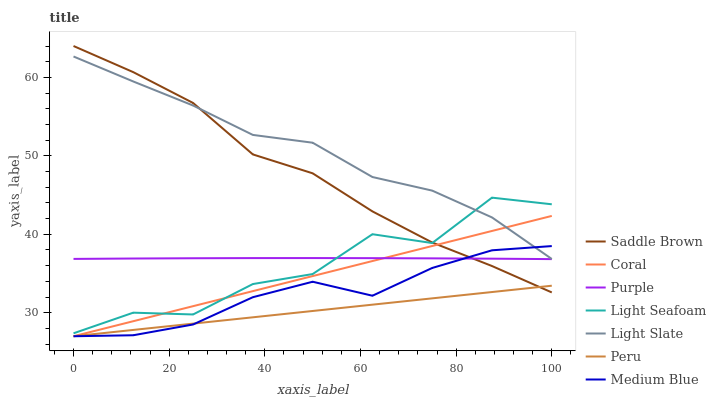Does Peru have the minimum area under the curve?
Answer yes or no. Yes. Does Light Slate have the maximum area under the curve?
Answer yes or no. Yes. Does Coral have the minimum area under the curve?
Answer yes or no. No. Does Coral have the maximum area under the curve?
Answer yes or no. No. Is Peru the smoothest?
Answer yes or no. Yes. Is Light Seafoam the roughest?
Answer yes or no. Yes. Is Coral the smoothest?
Answer yes or no. No. Is Coral the roughest?
Answer yes or no. No. Does Light Slate have the lowest value?
Answer yes or no. No. Does Coral have the highest value?
Answer yes or no. No. Is Purple less than Light Slate?
Answer yes or no. Yes. Is Light Slate greater than Peru?
Answer yes or no. Yes. Does Purple intersect Light Slate?
Answer yes or no. No. 